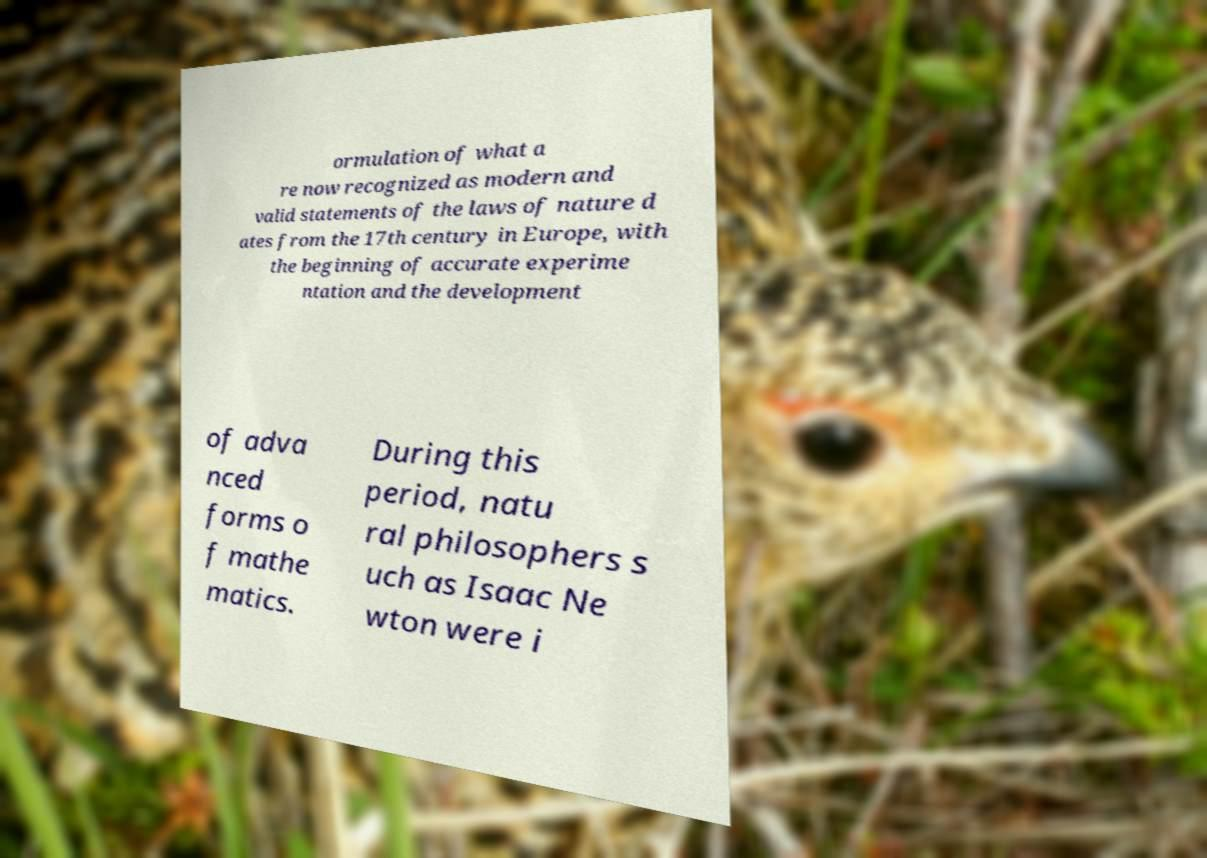I need the written content from this picture converted into text. Can you do that? ormulation of what a re now recognized as modern and valid statements of the laws of nature d ates from the 17th century in Europe, with the beginning of accurate experime ntation and the development of adva nced forms o f mathe matics. During this period, natu ral philosophers s uch as Isaac Ne wton were i 